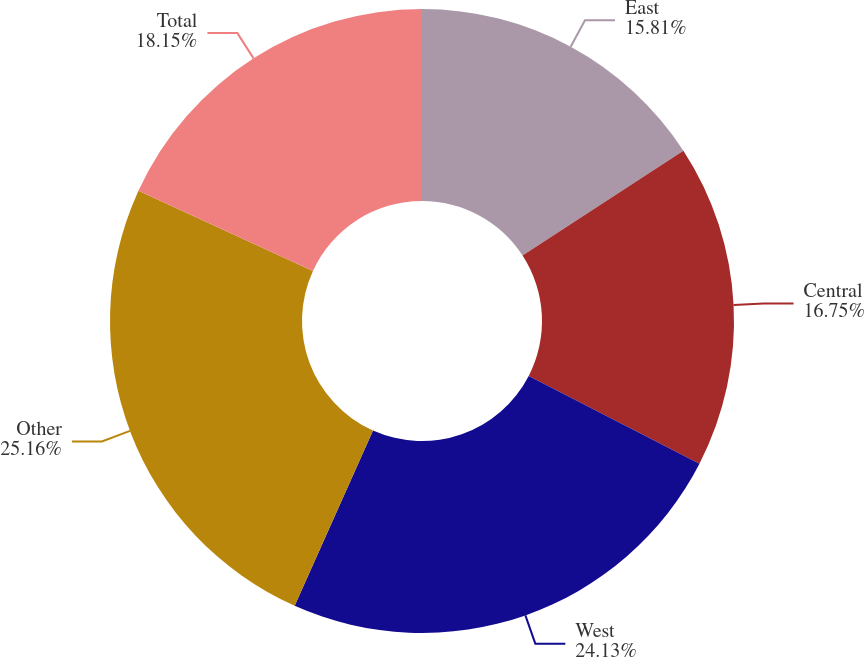<chart> <loc_0><loc_0><loc_500><loc_500><pie_chart><fcel>East<fcel>Central<fcel>West<fcel>Other<fcel>Total<nl><fcel>15.81%<fcel>16.75%<fcel>24.13%<fcel>25.16%<fcel>18.15%<nl></chart> 